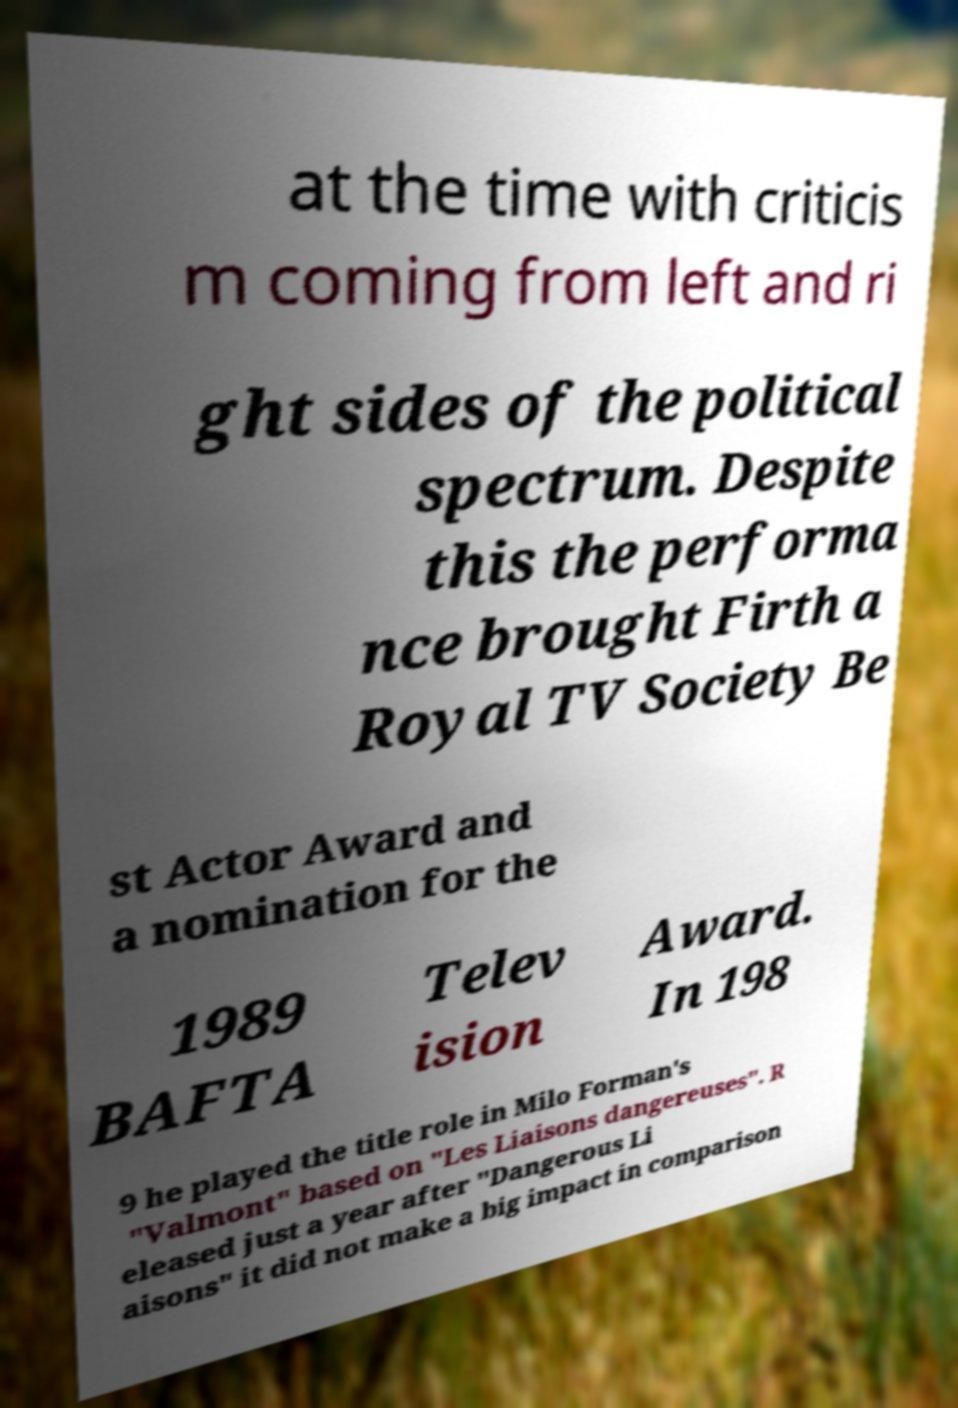Could you assist in decoding the text presented in this image and type it out clearly? at the time with criticis m coming from left and ri ght sides of the political spectrum. Despite this the performa nce brought Firth a Royal TV Society Be st Actor Award and a nomination for the 1989 BAFTA Telev ision Award. In 198 9 he played the title role in Milo Forman's "Valmont" based on "Les Liaisons dangereuses". R eleased just a year after "Dangerous Li aisons" it did not make a big impact in comparison 